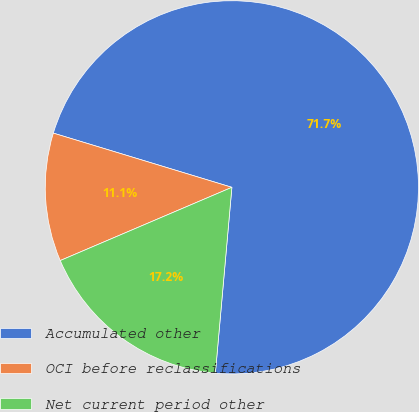Convert chart to OTSL. <chart><loc_0><loc_0><loc_500><loc_500><pie_chart><fcel>Accumulated other<fcel>OCI before reclassifications<fcel>Net current period other<nl><fcel>71.72%<fcel>11.11%<fcel>17.17%<nl></chart> 